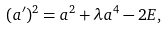Convert formula to latex. <formula><loc_0><loc_0><loc_500><loc_500>( a ^ { \prime } ) ^ { 2 } = a ^ { 2 } + \lambda a ^ { 4 } - 2 E ,</formula> 